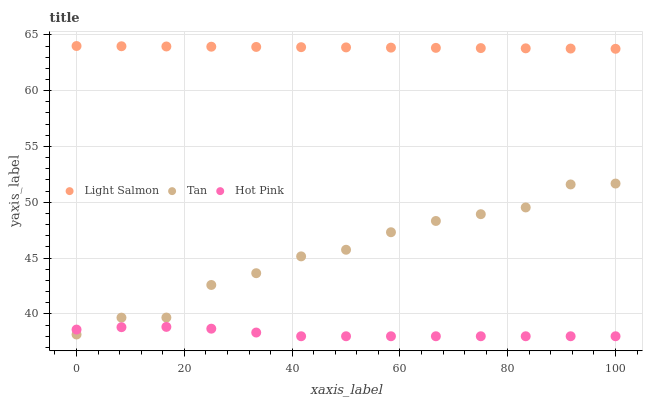Does Hot Pink have the minimum area under the curve?
Answer yes or no. Yes. Does Light Salmon have the maximum area under the curve?
Answer yes or no. Yes. Does Tan have the minimum area under the curve?
Answer yes or no. No. Does Tan have the maximum area under the curve?
Answer yes or no. No. Is Light Salmon the smoothest?
Answer yes or no. Yes. Is Tan the roughest?
Answer yes or no. Yes. Is Hot Pink the smoothest?
Answer yes or no. No. Is Hot Pink the roughest?
Answer yes or no. No. Does Hot Pink have the lowest value?
Answer yes or no. Yes. Does Tan have the lowest value?
Answer yes or no. No. Does Light Salmon have the highest value?
Answer yes or no. Yes. Does Tan have the highest value?
Answer yes or no. No. Is Hot Pink less than Light Salmon?
Answer yes or no. Yes. Is Light Salmon greater than Tan?
Answer yes or no. Yes. Does Hot Pink intersect Tan?
Answer yes or no. Yes. Is Hot Pink less than Tan?
Answer yes or no. No. Is Hot Pink greater than Tan?
Answer yes or no. No. Does Hot Pink intersect Light Salmon?
Answer yes or no. No. 